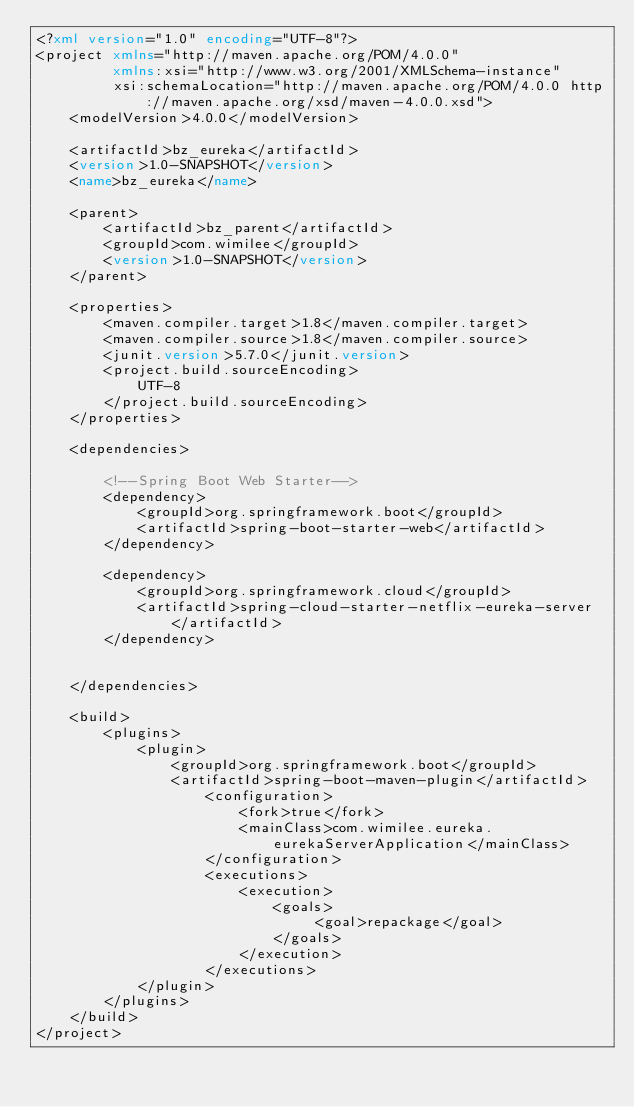<code> <loc_0><loc_0><loc_500><loc_500><_XML_><?xml version="1.0" encoding="UTF-8"?>
<project xmlns="http://maven.apache.org/POM/4.0.0"
         xmlns:xsi="http://www.w3.org/2001/XMLSchema-instance"
         xsi:schemaLocation="http://maven.apache.org/POM/4.0.0 http://maven.apache.org/xsd/maven-4.0.0.xsd">
    <modelVersion>4.0.0</modelVersion>

    <artifactId>bz_eureka</artifactId>
    <version>1.0-SNAPSHOT</version>
    <name>bz_eureka</name>

    <parent>
        <artifactId>bz_parent</artifactId>
        <groupId>com.wimilee</groupId>
        <version>1.0-SNAPSHOT</version>
    </parent>

    <properties>
        <maven.compiler.target>1.8</maven.compiler.target>
        <maven.compiler.source>1.8</maven.compiler.source>
        <junit.version>5.7.0</junit.version>
        <project.build.sourceEncoding>
            UTF-8
        </project.build.sourceEncoding>
    </properties>

    <dependencies>

        <!--Spring Boot Web Starter-->
        <dependency>
            <groupId>org.springframework.boot</groupId>
            <artifactId>spring-boot-starter-web</artifactId>
        </dependency>

        <dependency>
            <groupId>org.springframework.cloud</groupId>
            <artifactId>spring-cloud-starter-netflix-eureka-server</artifactId>
        </dependency>


    </dependencies>

    <build>
        <plugins>
            <plugin>
                <groupId>org.springframework.boot</groupId>
                <artifactId>spring-boot-maven-plugin</artifactId>
                    <configuration>
                        <fork>true</fork>
                        <mainClass>com.wimilee.eureka.eurekaServerApplication</mainClass>
                    </configuration>
                    <executions>
                        <execution>
                            <goals>
                                 <goal>repackage</goal>
                            </goals>
                        </execution>
                    </executions>
            </plugin>
        </plugins>
    </build>
</project></code> 